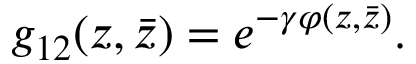Convert formula to latex. <formula><loc_0><loc_0><loc_500><loc_500>g _ { 1 2 } ( z , \bar { z } ) = e ^ { - \gamma \varphi ( z , \bar { z } ) } .</formula> 